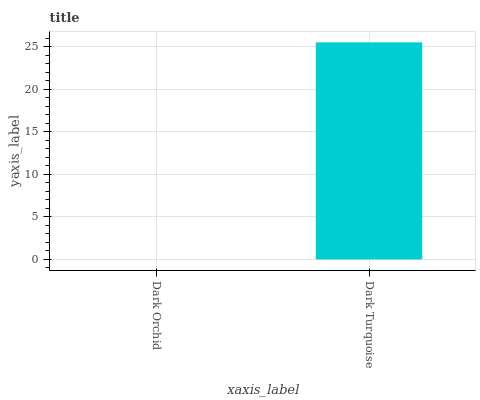Is Dark Orchid the minimum?
Answer yes or no. Yes. Is Dark Turquoise the maximum?
Answer yes or no. Yes. Is Dark Turquoise the minimum?
Answer yes or no. No. Is Dark Turquoise greater than Dark Orchid?
Answer yes or no. Yes. Is Dark Orchid less than Dark Turquoise?
Answer yes or no. Yes. Is Dark Orchid greater than Dark Turquoise?
Answer yes or no. No. Is Dark Turquoise less than Dark Orchid?
Answer yes or no. No. Is Dark Turquoise the high median?
Answer yes or no. Yes. Is Dark Orchid the low median?
Answer yes or no. Yes. Is Dark Orchid the high median?
Answer yes or no. No. Is Dark Turquoise the low median?
Answer yes or no. No. 